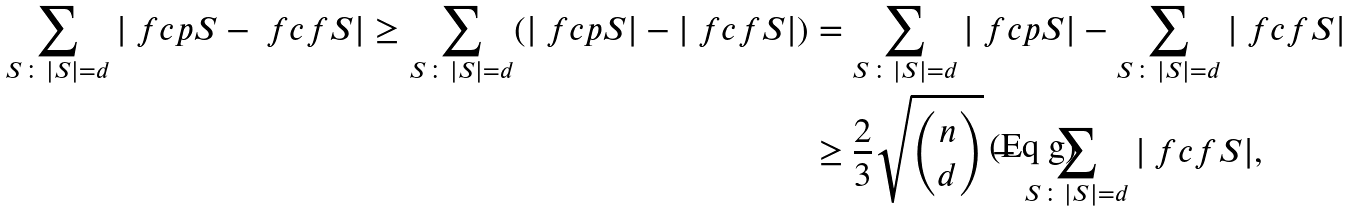<formula> <loc_0><loc_0><loc_500><loc_500>\sum _ { S \colon | S | = d } | \ f c { p } { S } - \ f c { f } { S } | \geq \sum _ { S \colon | S | = d } ( | \ f c { p } { S } | - | \ f c { f } { S } | ) & = \sum _ { S \colon | S | = d } | \ f c { p } { S } | - \sum _ { S \colon | S | = d } | \ f c { f } { S } | \\ & \geq \frac { 2 } { 3 } \sqrt { \binom { n } { d } } - \sum _ { S \colon | S | = d } | \ f c { f } { S } | ,</formula> 